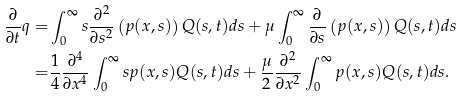Convert formula to latex. <formula><loc_0><loc_0><loc_500><loc_500>\frac { \partial } { \partial t } q = & \int _ { 0 } ^ { \infty } s \frac { \partial ^ { 2 } } { \partial s ^ { 2 } } \left ( p ( x , s ) \right ) Q ( s , t ) d s + \mu \int _ { 0 } ^ { \infty } \frac { \partial } { \partial s } \left ( p ( x , s ) \right ) Q ( s , t ) d s \\ = & \frac { 1 } { 4 } \frac { \partial ^ { 4 } } { \partial x ^ { 4 } } \int _ { 0 } ^ { \infty } s p ( x , s ) Q ( s , t ) d s + \frac { \mu } { 2 } \frac { \partial ^ { 2 } } { \partial x ^ { 2 } } \int _ { 0 } ^ { \infty } p ( x , s ) Q ( s , t ) d s .</formula> 